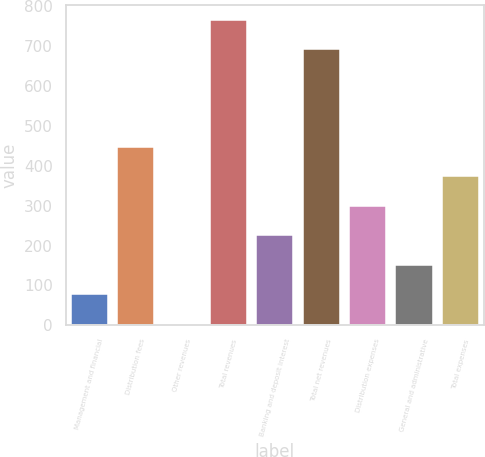Convert chart to OTSL. <chart><loc_0><loc_0><loc_500><loc_500><bar_chart><fcel>Management and financial<fcel>Distribution fees<fcel>Other revenues<fcel>Total revenues<fcel>Banking and deposit interest<fcel>Total net revenues<fcel>Distribution expenses<fcel>General and administrative<fcel>Total expenses<nl><fcel>78<fcel>448<fcel>4<fcel>766<fcel>226<fcel>692<fcel>300<fcel>152<fcel>374<nl></chart> 